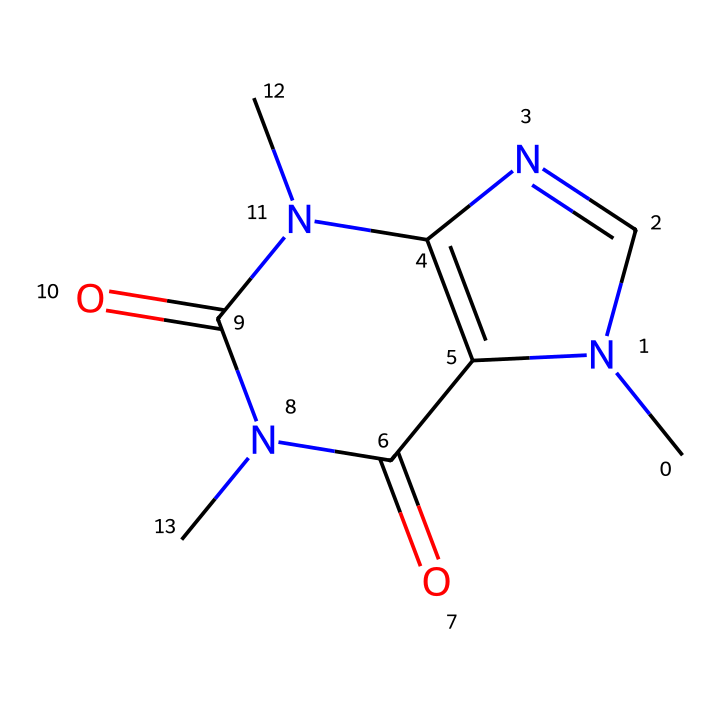What is the molecular formula of this chemical? To determine the molecular formula from the SMILES representation, count the number of each type of atom present in the structure. The SMILES indicates it contains 8 Carbon (C), 10 Hydrogen (H), 4 Nitrogen (N), and 2 Oxygen (O) atoms, leading to the formula C8H10N4O2.
Answer: C8H10N4O2 How many nitrogen atoms are present in the structure? By examining the SMILES, we can see that there are 4 occurrences of the letter 'N'. This indicates there are 4 nitrogen atoms in the chemical structure.
Answer: 4 What is the primary biological function of this compound? Caffeine primarily acts as a central nervous system stimulant, increasing alertness and reducing fatigue, as evidenced by its use in athletics and its structural properties.
Answer: stimulant Is this chemical classified as a hazardous substance? Caffeine, due to its stimulating properties and potential for harmful effects in excessive doses, is classified as a hazardous substance, which is particularly relevant in certain concentrations or contexts.
Answer: yes What type of chemical structure is caffeine? The structure revealed by the SMILES indicates it is an alkaloid, which is characterized by the presence of basic nitrogen atoms and is often bioactive, commonly found in plants.
Answer: alkaloid What is the total number of rings in the caffeine structure? The SMILES representation shows two connected ring structures (indicated by the numbers). Hence, there are 2 rings in the caffeine structure.
Answer: 2 